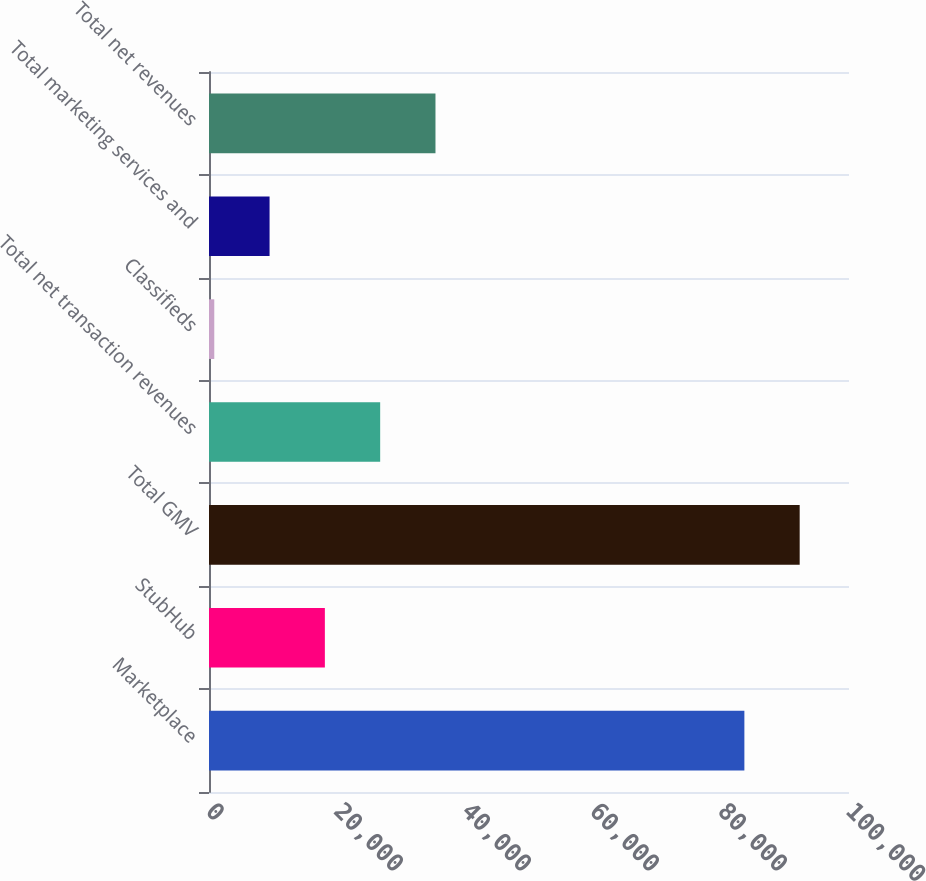Convert chart. <chart><loc_0><loc_0><loc_500><loc_500><bar_chart><fcel>Marketplace<fcel>StubHub<fcel>Total GMV<fcel>Total net transaction revenues<fcel>Classifieds<fcel>Total marketing services and<fcel>Total net revenues<nl><fcel>83653<fcel>18104.8<fcel>92293.9<fcel>26745.7<fcel>823<fcel>9463.9<fcel>35386.6<nl></chart> 